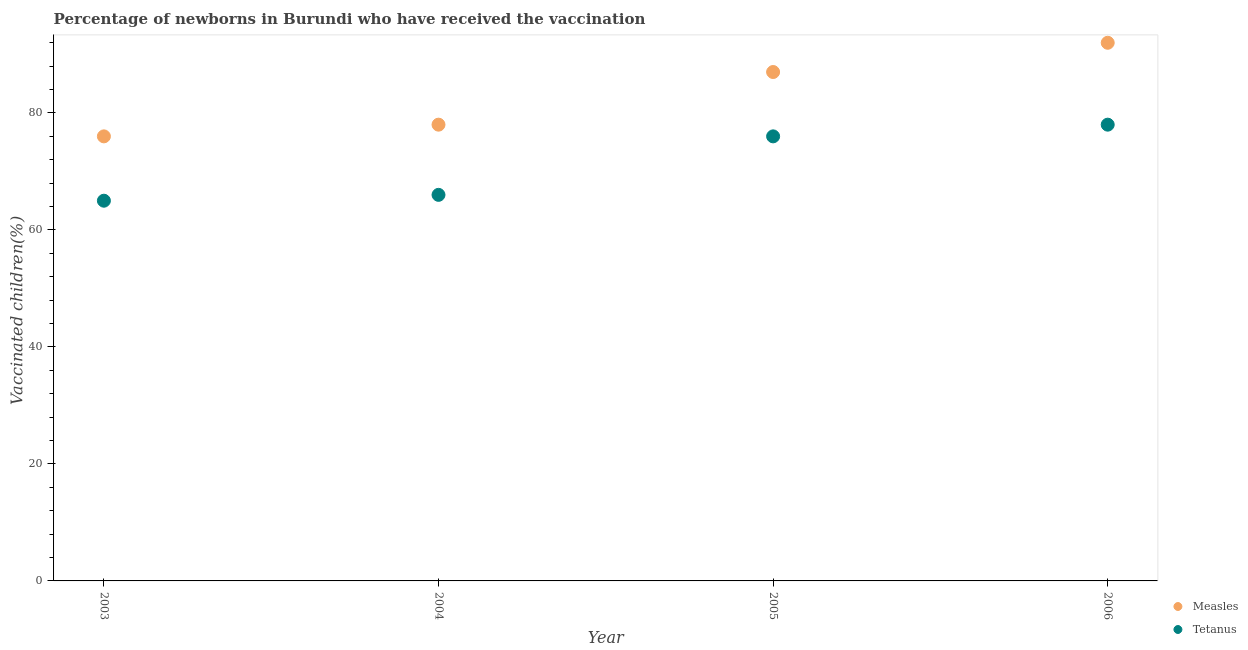How many different coloured dotlines are there?
Ensure brevity in your answer.  2. Is the number of dotlines equal to the number of legend labels?
Provide a succinct answer. Yes. What is the percentage of newborns who received vaccination for tetanus in 2004?
Your answer should be compact. 66. Across all years, what is the maximum percentage of newborns who received vaccination for measles?
Keep it short and to the point. 92. Across all years, what is the minimum percentage of newborns who received vaccination for measles?
Keep it short and to the point. 76. In which year was the percentage of newborns who received vaccination for measles maximum?
Provide a succinct answer. 2006. In which year was the percentage of newborns who received vaccination for measles minimum?
Ensure brevity in your answer.  2003. What is the total percentage of newborns who received vaccination for tetanus in the graph?
Your answer should be very brief. 285. What is the difference between the percentage of newborns who received vaccination for measles in 2004 and that in 2006?
Provide a succinct answer. -14. What is the average percentage of newborns who received vaccination for measles per year?
Your answer should be compact. 83.25. In the year 2004, what is the difference between the percentage of newborns who received vaccination for tetanus and percentage of newborns who received vaccination for measles?
Make the answer very short. -12. In how many years, is the percentage of newborns who received vaccination for tetanus greater than 12 %?
Offer a very short reply. 4. What is the ratio of the percentage of newborns who received vaccination for measles in 2003 to that in 2004?
Your response must be concise. 0.97. Is the percentage of newborns who received vaccination for measles in 2003 less than that in 2006?
Provide a succinct answer. Yes. Is the difference between the percentage of newborns who received vaccination for measles in 2004 and 2005 greater than the difference between the percentage of newborns who received vaccination for tetanus in 2004 and 2005?
Provide a succinct answer. Yes. What is the difference between the highest and the second highest percentage of newborns who received vaccination for tetanus?
Provide a succinct answer. 2. What is the difference between the highest and the lowest percentage of newborns who received vaccination for measles?
Ensure brevity in your answer.  16. In how many years, is the percentage of newborns who received vaccination for tetanus greater than the average percentage of newborns who received vaccination for tetanus taken over all years?
Keep it short and to the point. 2. Is the sum of the percentage of newborns who received vaccination for measles in 2003 and 2005 greater than the maximum percentage of newborns who received vaccination for tetanus across all years?
Offer a terse response. Yes. Does the percentage of newborns who received vaccination for tetanus monotonically increase over the years?
Provide a succinct answer. Yes. Is the percentage of newborns who received vaccination for measles strictly greater than the percentage of newborns who received vaccination for tetanus over the years?
Your answer should be very brief. Yes. How many dotlines are there?
Provide a succinct answer. 2. How many years are there in the graph?
Provide a short and direct response. 4. What is the difference between two consecutive major ticks on the Y-axis?
Your answer should be compact. 20. Are the values on the major ticks of Y-axis written in scientific E-notation?
Provide a succinct answer. No. Does the graph contain any zero values?
Ensure brevity in your answer.  No. Where does the legend appear in the graph?
Your answer should be compact. Bottom right. How many legend labels are there?
Your answer should be compact. 2. How are the legend labels stacked?
Keep it short and to the point. Vertical. What is the title of the graph?
Offer a terse response. Percentage of newborns in Burundi who have received the vaccination. Does "Under-five" appear as one of the legend labels in the graph?
Offer a very short reply. No. What is the label or title of the X-axis?
Give a very brief answer. Year. What is the label or title of the Y-axis?
Offer a terse response. Vaccinated children(%)
. What is the Vaccinated children(%)
 in Measles in 2003?
Make the answer very short. 76. What is the Vaccinated children(%)
 in Tetanus in 2003?
Ensure brevity in your answer.  65. What is the Vaccinated children(%)
 of Measles in 2005?
Your answer should be compact. 87. What is the Vaccinated children(%)
 in Tetanus in 2005?
Provide a succinct answer. 76. What is the Vaccinated children(%)
 of Measles in 2006?
Keep it short and to the point. 92. Across all years, what is the maximum Vaccinated children(%)
 of Measles?
Provide a succinct answer. 92. Across all years, what is the maximum Vaccinated children(%)
 of Tetanus?
Offer a very short reply. 78. Across all years, what is the minimum Vaccinated children(%)
 in Tetanus?
Offer a very short reply. 65. What is the total Vaccinated children(%)
 of Measles in the graph?
Provide a short and direct response. 333. What is the total Vaccinated children(%)
 in Tetanus in the graph?
Make the answer very short. 285. What is the difference between the Vaccinated children(%)
 in Measles in 2003 and that in 2005?
Ensure brevity in your answer.  -11. What is the difference between the Vaccinated children(%)
 in Measles in 2003 and that in 2006?
Your answer should be compact. -16. What is the difference between the Vaccinated children(%)
 of Measles in 2004 and that in 2005?
Ensure brevity in your answer.  -9. What is the difference between the Vaccinated children(%)
 of Measles in 2004 and that in 2006?
Your answer should be compact. -14. What is the difference between the Vaccinated children(%)
 of Tetanus in 2004 and that in 2006?
Ensure brevity in your answer.  -12. What is the difference between the Vaccinated children(%)
 of Tetanus in 2005 and that in 2006?
Your answer should be very brief. -2. What is the difference between the Vaccinated children(%)
 of Measles in 2003 and the Vaccinated children(%)
 of Tetanus in 2004?
Keep it short and to the point. 10. What is the difference between the Vaccinated children(%)
 of Measles in 2004 and the Vaccinated children(%)
 of Tetanus in 2005?
Give a very brief answer. 2. What is the difference between the Vaccinated children(%)
 in Measles in 2004 and the Vaccinated children(%)
 in Tetanus in 2006?
Provide a succinct answer. 0. What is the difference between the Vaccinated children(%)
 of Measles in 2005 and the Vaccinated children(%)
 of Tetanus in 2006?
Offer a terse response. 9. What is the average Vaccinated children(%)
 of Measles per year?
Provide a succinct answer. 83.25. What is the average Vaccinated children(%)
 of Tetanus per year?
Make the answer very short. 71.25. In the year 2003, what is the difference between the Vaccinated children(%)
 in Measles and Vaccinated children(%)
 in Tetanus?
Your response must be concise. 11. In the year 2005, what is the difference between the Vaccinated children(%)
 of Measles and Vaccinated children(%)
 of Tetanus?
Make the answer very short. 11. In the year 2006, what is the difference between the Vaccinated children(%)
 in Measles and Vaccinated children(%)
 in Tetanus?
Your response must be concise. 14. What is the ratio of the Vaccinated children(%)
 in Measles in 2003 to that in 2004?
Offer a terse response. 0.97. What is the ratio of the Vaccinated children(%)
 in Tetanus in 2003 to that in 2004?
Provide a succinct answer. 0.98. What is the ratio of the Vaccinated children(%)
 of Measles in 2003 to that in 2005?
Your answer should be very brief. 0.87. What is the ratio of the Vaccinated children(%)
 in Tetanus in 2003 to that in 2005?
Keep it short and to the point. 0.86. What is the ratio of the Vaccinated children(%)
 in Measles in 2003 to that in 2006?
Your response must be concise. 0.83. What is the ratio of the Vaccinated children(%)
 in Tetanus in 2003 to that in 2006?
Your response must be concise. 0.83. What is the ratio of the Vaccinated children(%)
 in Measles in 2004 to that in 2005?
Your response must be concise. 0.9. What is the ratio of the Vaccinated children(%)
 of Tetanus in 2004 to that in 2005?
Your response must be concise. 0.87. What is the ratio of the Vaccinated children(%)
 of Measles in 2004 to that in 2006?
Your response must be concise. 0.85. What is the ratio of the Vaccinated children(%)
 in Tetanus in 2004 to that in 2006?
Your answer should be very brief. 0.85. What is the ratio of the Vaccinated children(%)
 of Measles in 2005 to that in 2006?
Keep it short and to the point. 0.95. What is the ratio of the Vaccinated children(%)
 in Tetanus in 2005 to that in 2006?
Make the answer very short. 0.97. What is the difference between the highest and the lowest Vaccinated children(%)
 in Tetanus?
Provide a succinct answer. 13. 